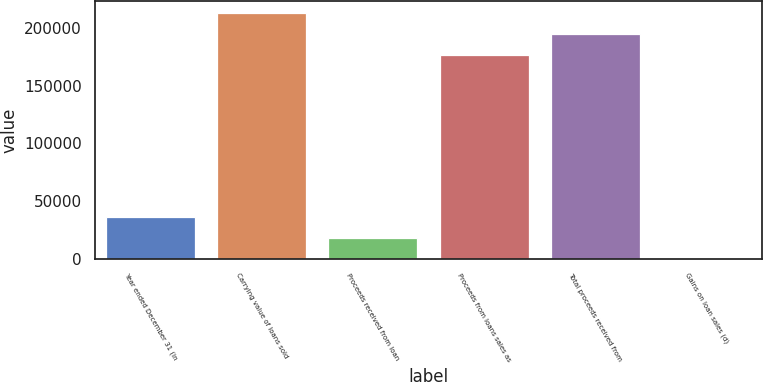Convert chart to OTSL. <chart><loc_0><loc_0><loc_500><loc_500><bar_chart><fcel>Year ended December 31 (in<fcel>Carrying value of loans sold<fcel>Proceeds received from loan<fcel>Proceeds from loans sales as<fcel>Total proceeds received from<fcel>Gains on loan sales (d)<nl><fcel>35914.4<fcel>212365<fcel>18027.7<fcel>176592<fcel>194479<fcel>141<nl></chart> 